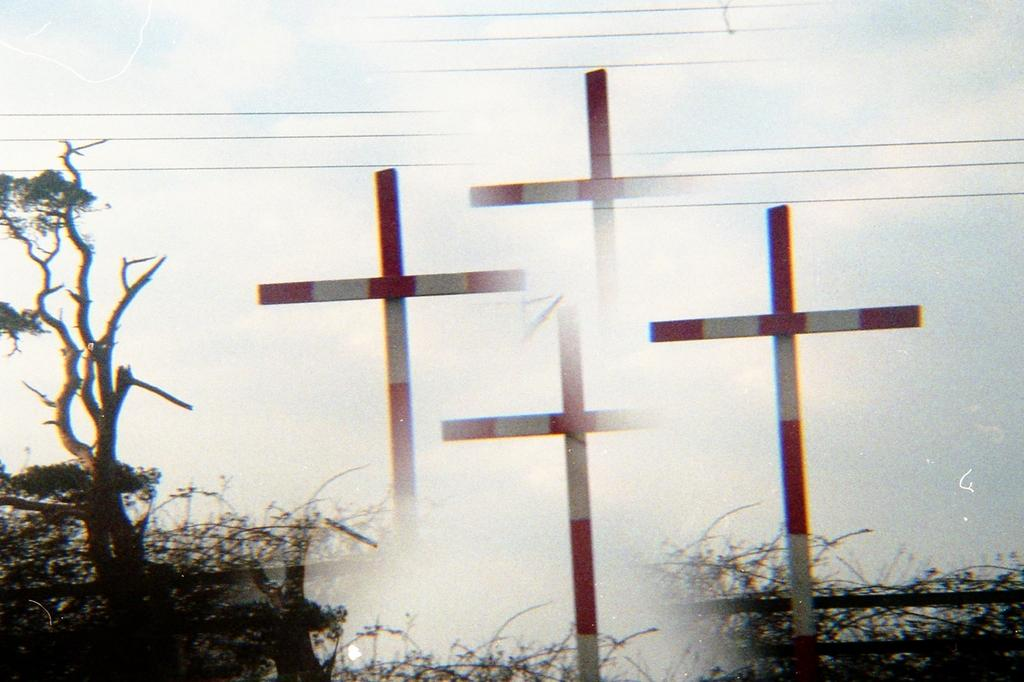What symbols are present in the foreground of the image? There are four cross symbols in the foreground of the image. What type of natural elements can be seen in the image? There are trees in the image. What man-made structures are visible in the image? Cables are visible in the image. What part of the environment is visible in the image? The sky is visible in the image. What religious figure is seen pushing the trees in the image? There is no religious figure or pushing action depicted in the image; it only features cross symbols, trees, cables, and the sky. 